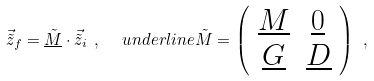<formula> <loc_0><loc_0><loc_500><loc_500>\vec { \tilde { z } } _ { f } = \underline { \tilde { M } } \cdot \vec { \tilde { z } } _ { i } \ , \ \ \ u n d e r l i n e { \tilde { M } } = \left ( \begin{array} { c c } \underline { M } & \underline { 0 } \\ \underline { G } & \underline { D } \end{array} \right ) \ ,</formula> 